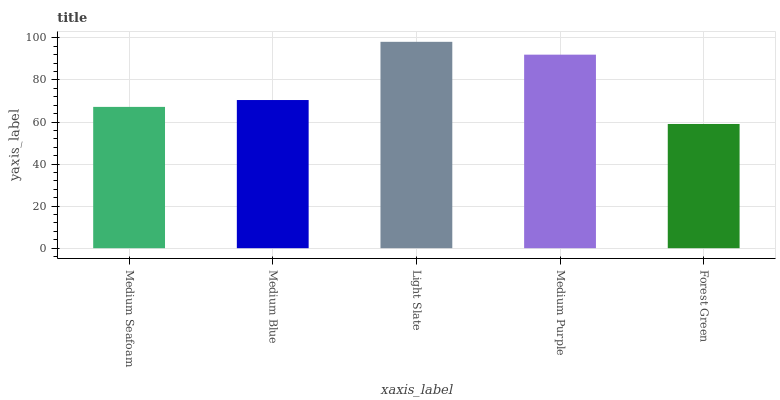Is Medium Blue the minimum?
Answer yes or no. No. Is Medium Blue the maximum?
Answer yes or no. No. Is Medium Blue greater than Medium Seafoam?
Answer yes or no. Yes. Is Medium Seafoam less than Medium Blue?
Answer yes or no. Yes. Is Medium Seafoam greater than Medium Blue?
Answer yes or no. No. Is Medium Blue less than Medium Seafoam?
Answer yes or no. No. Is Medium Blue the high median?
Answer yes or no. Yes. Is Medium Blue the low median?
Answer yes or no. Yes. Is Medium Purple the high median?
Answer yes or no. No. Is Forest Green the low median?
Answer yes or no. No. 